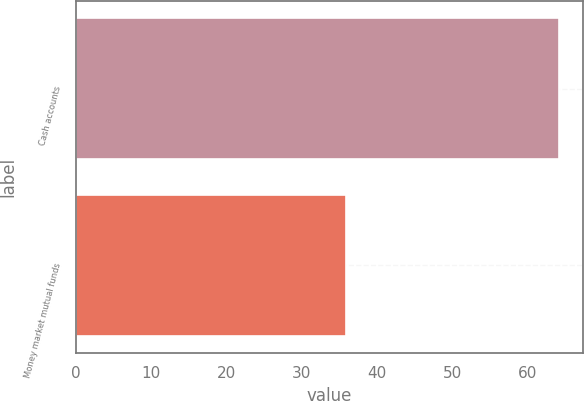Convert chart to OTSL. <chart><loc_0><loc_0><loc_500><loc_500><bar_chart><fcel>Cash accounts<fcel>Money market mutual funds<nl><fcel>64.1<fcel>35.9<nl></chart> 